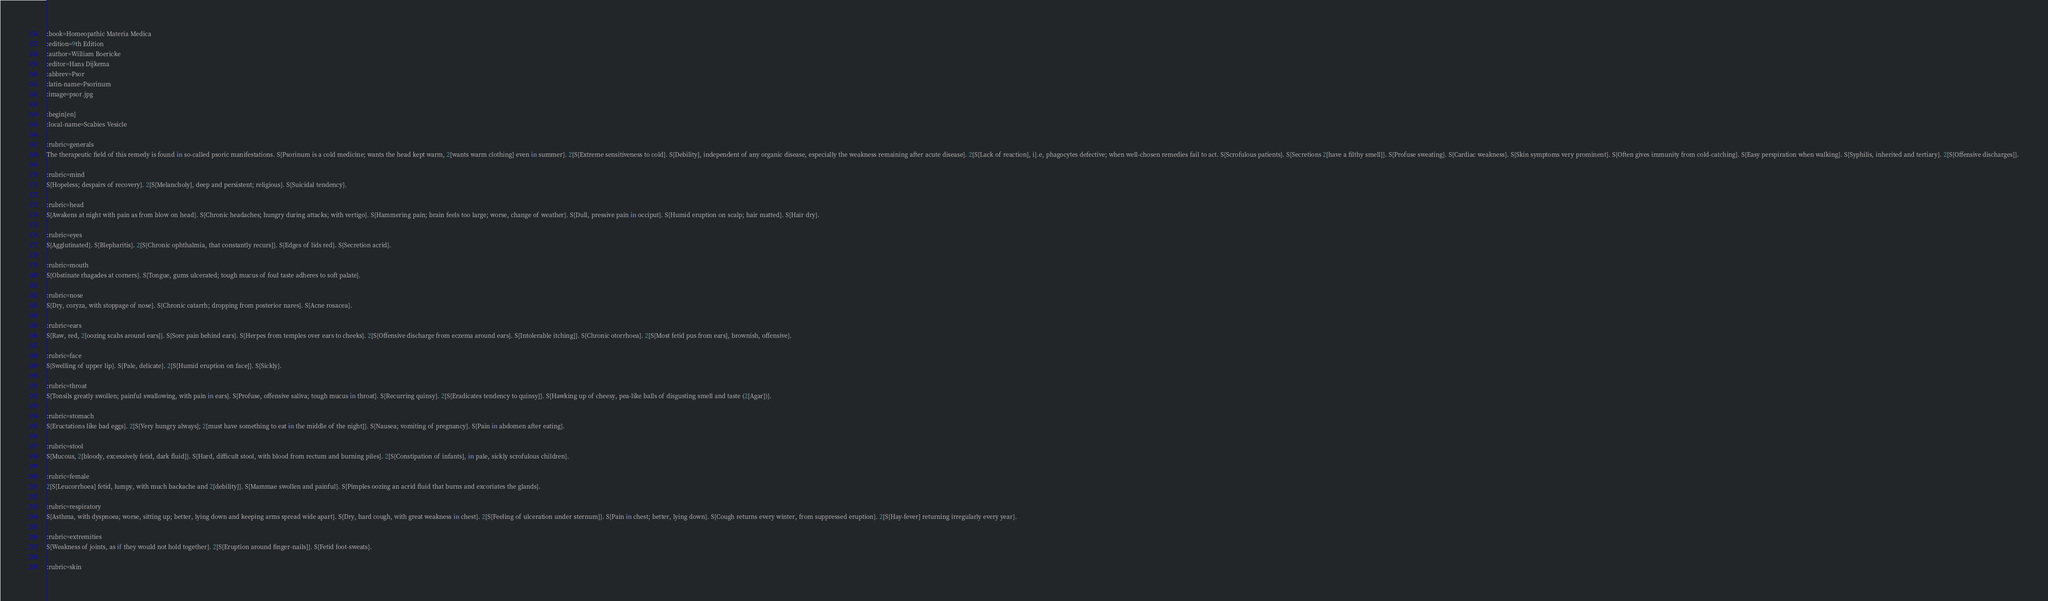Convert code to text. <code><loc_0><loc_0><loc_500><loc_500><_ObjectiveC_>:book=Homeopathic Materia Medica
:edition=9th Edition
:author=William Boericke
:editor=Hans Dijkema
:abbrev=Psor
:latin-name=Psorinum
:image=psor.jpg

:begin[en]
:local-name=Scabies Vesicle

:rubric=generals
The therapeutic field of this remedy is found in so-called psoric manifestations. S{Psorinum is a cold medicine; wants the head kept warm, 2[wants warm clothing] even in summer}. 2[S{Extreme sensitiveness to cold}. S{Debility], independent of any organic disease, especially the weakness remaining after acute disease}. 2[S{Lack of reaction], i}.e, phagocytes defective; when well-chosen remedies fail to act. S{Scrofulous patients}. S{Secretions 2[have a filthy smell]}. S{Profuse sweating}. S{Cardiac weakness}. S{Skin symptoms very prominent}. S{Often gives immunity from cold-catching}. S{Easy perspiration when walking}. S{Syphilis, inherited and tertiary}. 2[S{Offensive discharges]}.

:rubric=mind
S{Hopeless; despairs of recovery}. 2[S{Melancholy], deep and persistent; religious}. S{Suicidal tendency}.

:rubric=head
S{Awakens at night with pain as from blow on head}. S{Chronic headaches; hungry during attacks; with vertigo}. S{Hammering pain; brain feels too large; worse, change of weather}. S{Dull, pressive pain in occiput}. S{Humid eruption on scalp; hair matted}. S{Hair dry}.

:rubric=eyes
S{Agglutinated}. S{Blepharitis}. 2[S{Chronic ophthalmia, that constantly recurs]}. S{Edges of lids red}. S{Secretion acrid}.

:rubric=mouth
S{Obstinate rhagades at corners}. S{Tongue, gums ulcerated; tough mucus of foul taste adheres to soft palate}.

:rubric=nose
S{Dry, coryza, with stoppage of nose}. S{Chronic catarrh; dropping from posterior nares}. S{Acne rosacea}.

:rubric=ears
S{Raw, red, 2[oozing scabs around ears]}. S{Sore pain behind ears}. S{Herpes from temples over ears to cheeks}. 2[S{Offensive discharge from eczema around ears}. S{Intolerable itching]}. S{Chronic otorrhoea}. 2[S{Most fetid pus from ears], brownish, offensive}.

:rubric=face
S{Swelling of upper lip}. S{Pale, delicate}. 2[S{Humid eruption on face]}. S{Sickly}.

:rubric=throat
S{Tonsils greatly swollen; painful swallowing, with pain in ears}. S{Profuse, offensive saliva; tough mucus in throat}. S{Recurring quinsy}. 2[S{Eradicates tendency to quinsy]}. S{Hawking up of cheesy, pea-like balls of disgusting smell and taste (2[Agar])}.

:rubric=stomach
S{Eructations like bad eggs}. 2[S{Very hungry always]; 2[must have something to eat in the middle of the night]}. S{Nausea; vomiting of pregnancy}. S{Pain in abdomen after eating}.

:rubric=stool
S{Mucous, 2[bloody, excessively fetid, dark fluid]}. S{Hard, difficult stool, with blood from rectum and burning piles}. 2[S{Constipation of infants], in pale, sickly scrofulous children}.

:rubric=female
2[S{Leucorrhoea] fetid, lumpy, with much backache and 2[debility]}. S{Mammae swollen and painful}. S{Pimples oozing an acrid fluid that burns and excoriates the glands}.

:rubric=respiratory
S{Asthma, with dyspnoea; worse, sitting up; better, lying down and keeping arms spread wide apart}. S{Dry, hard cough, with great weakness in chest}. 2[S{Feeling of ulceration under sternum]}. S{Pain in chest; better, lying down}. S{Cough returns every winter, from suppressed eruption}. 2[S{Hay-fever] returning irregularly every year}.

:rubric=extremities
S{Weakness of joints, as if they would not hold together}. 2[S{Eruption around finger-nails]}. S{Fetid foot-sweats}.

:rubric=skin</code> 